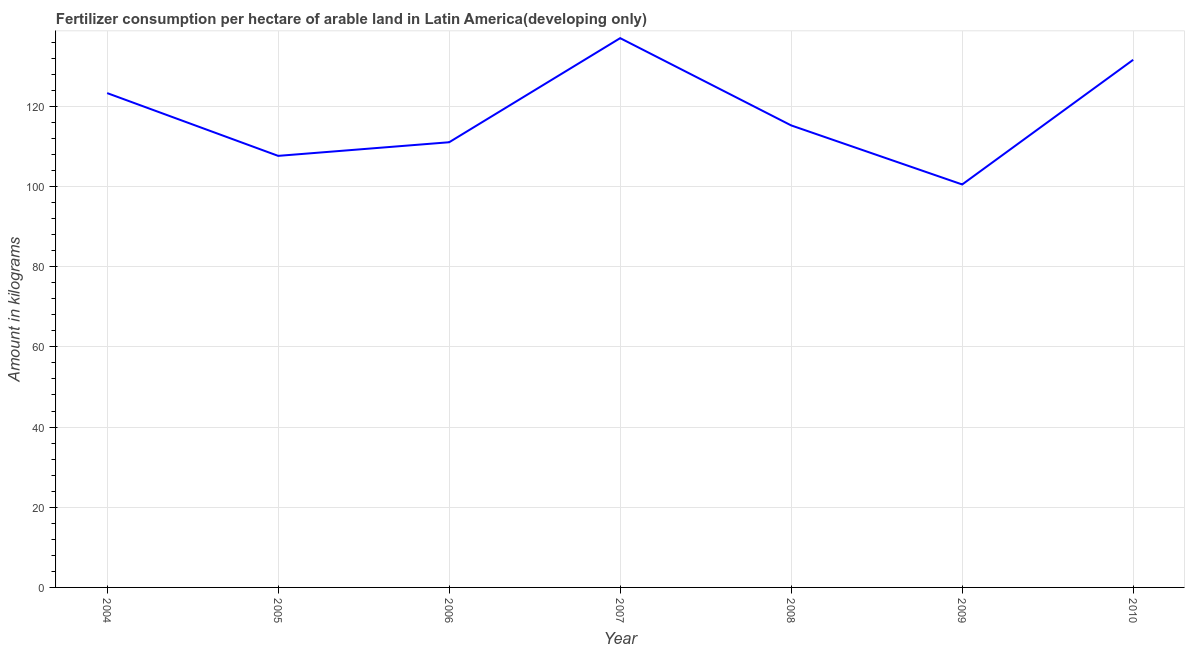What is the amount of fertilizer consumption in 2009?
Keep it short and to the point. 100.52. Across all years, what is the maximum amount of fertilizer consumption?
Your answer should be very brief. 137.02. Across all years, what is the minimum amount of fertilizer consumption?
Keep it short and to the point. 100.52. In which year was the amount of fertilizer consumption maximum?
Keep it short and to the point. 2007. In which year was the amount of fertilizer consumption minimum?
Give a very brief answer. 2009. What is the sum of the amount of fertilizer consumption?
Provide a short and direct response. 826.4. What is the difference between the amount of fertilizer consumption in 2007 and 2008?
Offer a very short reply. 21.77. What is the average amount of fertilizer consumption per year?
Offer a very short reply. 118.06. What is the median amount of fertilizer consumption?
Ensure brevity in your answer.  115.25. Do a majority of the years between 2010 and 2005 (inclusive) have amount of fertilizer consumption greater than 64 kg?
Offer a terse response. Yes. What is the ratio of the amount of fertilizer consumption in 2008 to that in 2010?
Provide a succinct answer. 0.88. What is the difference between the highest and the second highest amount of fertilizer consumption?
Provide a short and direct response. 5.4. What is the difference between the highest and the lowest amount of fertilizer consumption?
Make the answer very short. 36.5. Does the amount of fertilizer consumption monotonically increase over the years?
Give a very brief answer. No. What is the difference between two consecutive major ticks on the Y-axis?
Give a very brief answer. 20. Are the values on the major ticks of Y-axis written in scientific E-notation?
Provide a short and direct response. No. Does the graph contain any zero values?
Your answer should be compact. No. Does the graph contain grids?
Your response must be concise. Yes. What is the title of the graph?
Ensure brevity in your answer.  Fertilizer consumption per hectare of arable land in Latin America(developing only) . What is the label or title of the X-axis?
Make the answer very short. Year. What is the label or title of the Y-axis?
Your answer should be compact. Amount in kilograms. What is the Amount in kilograms in 2004?
Make the answer very short. 123.31. What is the Amount in kilograms in 2005?
Offer a very short reply. 107.65. What is the Amount in kilograms in 2006?
Your response must be concise. 111.05. What is the Amount in kilograms in 2007?
Provide a succinct answer. 137.02. What is the Amount in kilograms of 2008?
Ensure brevity in your answer.  115.25. What is the Amount in kilograms of 2009?
Give a very brief answer. 100.52. What is the Amount in kilograms in 2010?
Make the answer very short. 131.62. What is the difference between the Amount in kilograms in 2004 and 2005?
Ensure brevity in your answer.  15.66. What is the difference between the Amount in kilograms in 2004 and 2006?
Your answer should be very brief. 12.26. What is the difference between the Amount in kilograms in 2004 and 2007?
Offer a very short reply. -13.71. What is the difference between the Amount in kilograms in 2004 and 2008?
Make the answer very short. 8.06. What is the difference between the Amount in kilograms in 2004 and 2009?
Your answer should be very brief. 22.79. What is the difference between the Amount in kilograms in 2004 and 2010?
Your response must be concise. -8.31. What is the difference between the Amount in kilograms in 2005 and 2006?
Your answer should be very brief. -3.4. What is the difference between the Amount in kilograms in 2005 and 2007?
Give a very brief answer. -29.37. What is the difference between the Amount in kilograms in 2005 and 2008?
Offer a terse response. -7.6. What is the difference between the Amount in kilograms in 2005 and 2009?
Provide a short and direct response. 7.13. What is the difference between the Amount in kilograms in 2005 and 2010?
Make the answer very short. -23.97. What is the difference between the Amount in kilograms in 2006 and 2007?
Keep it short and to the point. -25.97. What is the difference between the Amount in kilograms in 2006 and 2008?
Give a very brief answer. -4.2. What is the difference between the Amount in kilograms in 2006 and 2009?
Provide a short and direct response. 10.53. What is the difference between the Amount in kilograms in 2006 and 2010?
Offer a terse response. -20.57. What is the difference between the Amount in kilograms in 2007 and 2008?
Provide a short and direct response. 21.77. What is the difference between the Amount in kilograms in 2007 and 2009?
Keep it short and to the point. 36.5. What is the difference between the Amount in kilograms in 2007 and 2010?
Your response must be concise. 5.4. What is the difference between the Amount in kilograms in 2008 and 2009?
Make the answer very short. 14.73. What is the difference between the Amount in kilograms in 2008 and 2010?
Give a very brief answer. -16.37. What is the difference between the Amount in kilograms in 2009 and 2010?
Provide a short and direct response. -31.1. What is the ratio of the Amount in kilograms in 2004 to that in 2005?
Keep it short and to the point. 1.15. What is the ratio of the Amount in kilograms in 2004 to that in 2006?
Give a very brief answer. 1.11. What is the ratio of the Amount in kilograms in 2004 to that in 2008?
Your answer should be very brief. 1.07. What is the ratio of the Amount in kilograms in 2004 to that in 2009?
Make the answer very short. 1.23. What is the ratio of the Amount in kilograms in 2004 to that in 2010?
Make the answer very short. 0.94. What is the ratio of the Amount in kilograms in 2005 to that in 2007?
Offer a very short reply. 0.79. What is the ratio of the Amount in kilograms in 2005 to that in 2008?
Your answer should be compact. 0.93. What is the ratio of the Amount in kilograms in 2005 to that in 2009?
Keep it short and to the point. 1.07. What is the ratio of the Amount in kilograms in 2005 to that in 2010?
Make the answer very short. 0.82. What is the ratio of the Amount in kilograms in 2006 to that in 2007?
Provide a short and direct response. 0.81. What is the ratio of the Amount in kilograms in 2006 to that in 2009?
Ensure brevity in your answer.  1.1. What is the ratio of the Amount in kilograms in 2006 to that in 2010?
Offer a very short reply. 0.84. What is the ratio of the Amount in kilograms in 2007 to that in 2008?
Offer a very short reply. 1.19. What is the ratio of the Amount in kilograms in 2007 to that in 2009?
Offer a terse response. 1.36. What is the ratio of the Amount in kilograms in 2007 to that in 2010?
Make the answer very short. 1.04. What is the ratio of the Amount in kilograms in 2008 to that in 2009?
Your answer should be compact. 1.15. What is the ratio of the Amount in kilograms in 2008 to that in 2010?
Offer a terse response. 0.88. What is the ratio of the Amount in kilograms in 2009 to that in 2010?
Your answer should be compact. 0.76. 